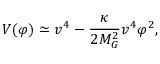<formula> <loc_0><loc_0><loc_500><loc_500>V ( \varphi ) \simeq v ^ { 4 } - \frac { \kappa } { 2 M _ { G } ^ { 2 } } v ^ { 4 } \varphi ^ { 2 } ,</formula> 